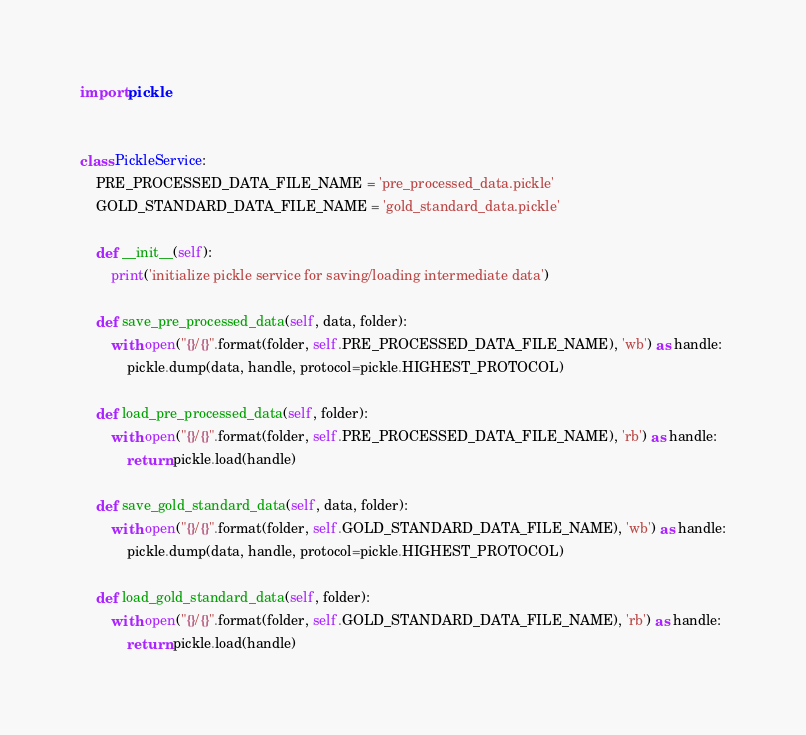Convert code to text. <code><loc_0><loc_0><loc_500><loc_500><_Python_>import pickle


class PickleService:
    PRE_PROCESSED_DATA_FILE_NAME = 'pre_processed_data.pickle'
    GOLD_STANDARD_DATA_FILE_NAME = 'gold_standard_data.pickle'

    def __init__(self):
        print('initialize pickle service for saving/loading intermediate data')

    def save_pre_processed_data(self, data, folder):
        with open("{}/{}".format(folder, self.PRE_PROCESSED_DATA_FILE_NAME), 'wb') as handle:
            pickle.dump(data, handle, protocol=pickle.HIGHEST_PROTOCOL)

    def load_pre_processed_data(self, folder):
        with open("{}/{}".format(folder, self.PRE_PROCESSED_DATA_FILE_NAME), 'rb') as handle:
            return pickle.load(handle)

    def save_gold_standard_data(self, data, folder):
        with open("{}/{}".format(folder, self.GOLD_STANDARD_DATA_FILE_NAME), 'wb') as handle:
            pickle.dump(data, handle, protocol=pickle.HIGHEST_PROTOCOL)

    def load_gold_standard_data(self, folder):
        with open("{}/{}".format(folder, self.GOLD_STANDARD_DATA_FILE_NAME), 'rb') as handle:
            return pickle.load(handle)
</code> 